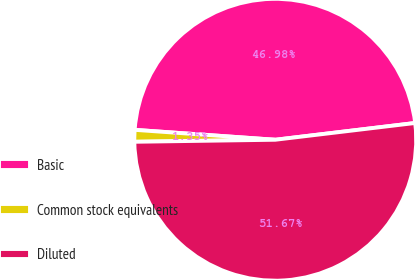<chart> <loc_0><loc_0><loc_500><loc_500><pie_chart><fcel>Basic<fcel>Common stock equivalents<fcel>Diluted<nl><fcel>46.98%<fcel>1.35%<fcel>51.67%<nl></chart> 